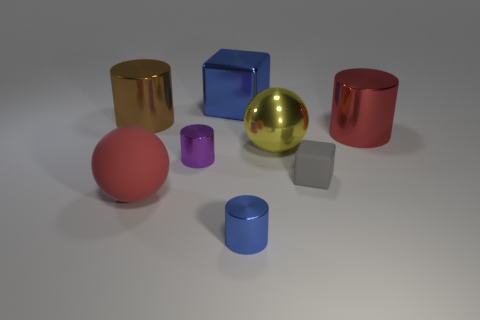Subtract all gray cylinders. Subtract all green balls. How many cylinders are left? 4 Add 2 large cyan matte cubes. How many objects exist? 10 Subtract all balls. How many objects are left? 6 Subtract all large yellow things. Subtract all blue cylinders. How many objects are left? 6 Add 4 tiny gray things. How many tiny gray things are left? 5 Add 5 large red things. How many large red things exist? 7 Subtract 0 cyan balls. How many objects are left? 8 